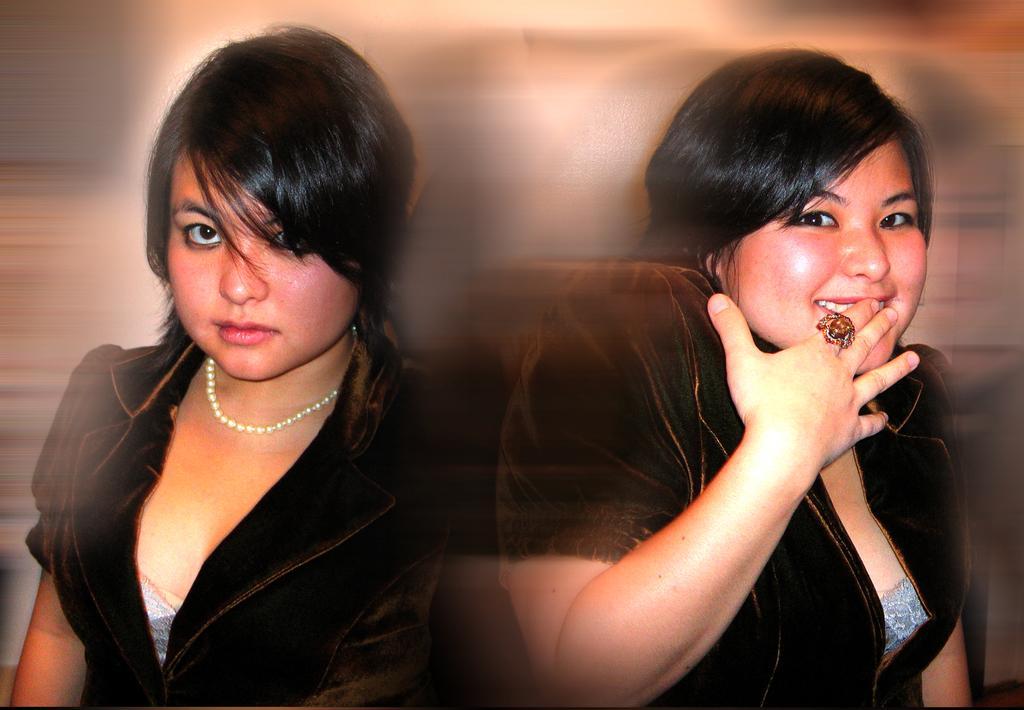Can you describe this image briefly? In this image there are two women, in the background it is blurred. 